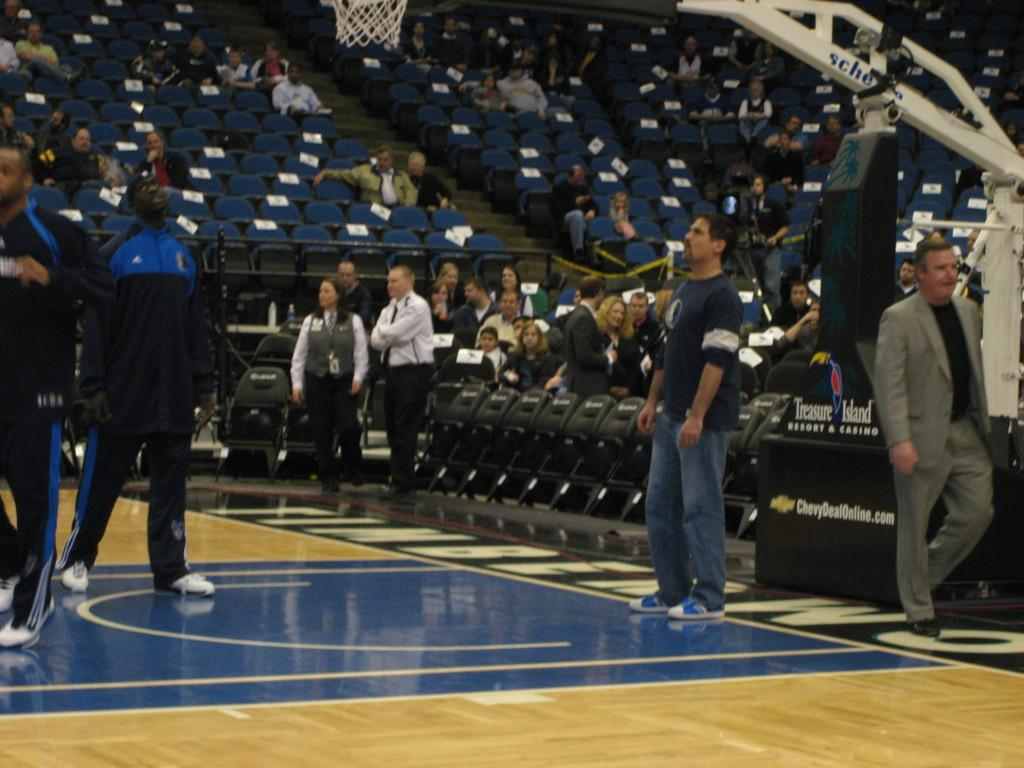Where was the image taken? The image was taken in a stadium. What can be seen in the image besides the stadium? There are chairs, people sitting on the chairs, people standing in the middle of the image, and a basketball net at the top of the image. What is the size of the church in the image? There is no church present in the image. Can you tell me the color of the tank in the image? There is no tank present in the image. 